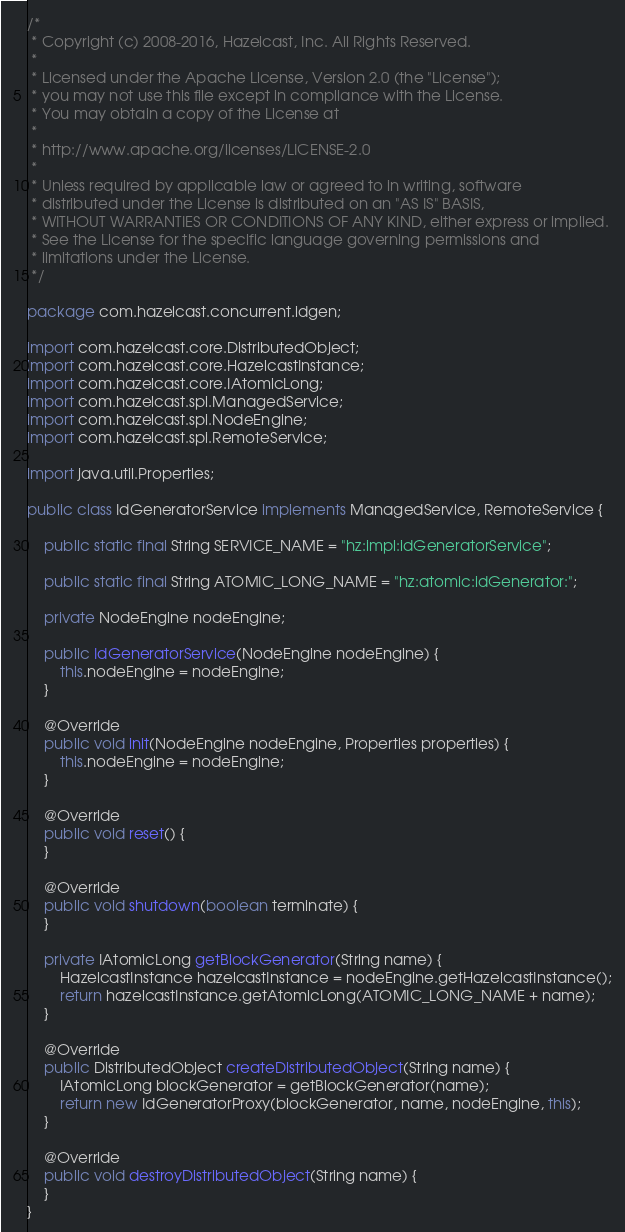<code> <loc_0><loc_0><loc_500><loc_500><_Java_>/*
 * Copyright (c) 2008-2016, Hazelcast, Inc. All Rights Reserved.
 *
 * Licensed under the Apache License, Version 2.0 (the "License");
 * you may not use this file except in compliance with the License.
 * You may obtain a copy of the License at
 *
 * http://www.apache.org/licenses/LICENSE-2.0
 *
 * Unless required by applicable law or agreed to in writing, software
 * distributed under the License is distributed on an "AS IS" BASIS,
 * WITHOUT WARRANTIES OR CONDITIONS OF ANY KIND, either express or implied.
 * See the License for the specific language governing permissions and
 * limitations under the License.
 */

package com.hazelcast.concurrent.idgen;

import com.hazelcast.core.DistributedObject;
import com.hazelcast.core.HazelcastInstance;
import com.hazelcast.core.IAtomicLong;
import com.hazelcast.spi.ManagedService;
import com.hazelcast.spi.NodeEngine;
import com.hazelcast.spi.RemoteService;

import java.util.Properties;

public class IdGeneratorService implements ManagedService, RemoteService {

    public static final String SERVICE_NAME = "hz:impl:idGeneratorService";

    public static final String ATOMIC_LONG_NAME = "hz:atomic:idGenerator:";

    private NodeEngine nodeEngine;

    public IdGeneratorService(NodeEngine nodeEngine) {
        this.nodeEngine = nodeEngine;
    }

    @Override
    public void init(NodeEngine nodeEngine, Properties properties) {
        this.nodeEngine = nodeEngine;
    }

    @Override
    public void reset() {
    }

    @Override
    public void shutdown(boolean terminate) {
    }

    private IAtomicLong getBlockGenerator(String name) {
        HazelcastInstance hazelcastInstance = nodeEngine.getHazelcastInstance();
        return hazelcastInstance.getAtomicLong(ATOMIC_LONG_NAME + name);
    }

    @Override
    public DistributedObject createDistributedObject(String name) {
        IAtomicLong blockGenerator = getBlockGenerator(name);
        return new IdGeneratorProxy(blockGenerator, name, nodeEngine, this);
    }

    @Override
    public void destroyDistributedObject(String name) {
    }
}
</code> 